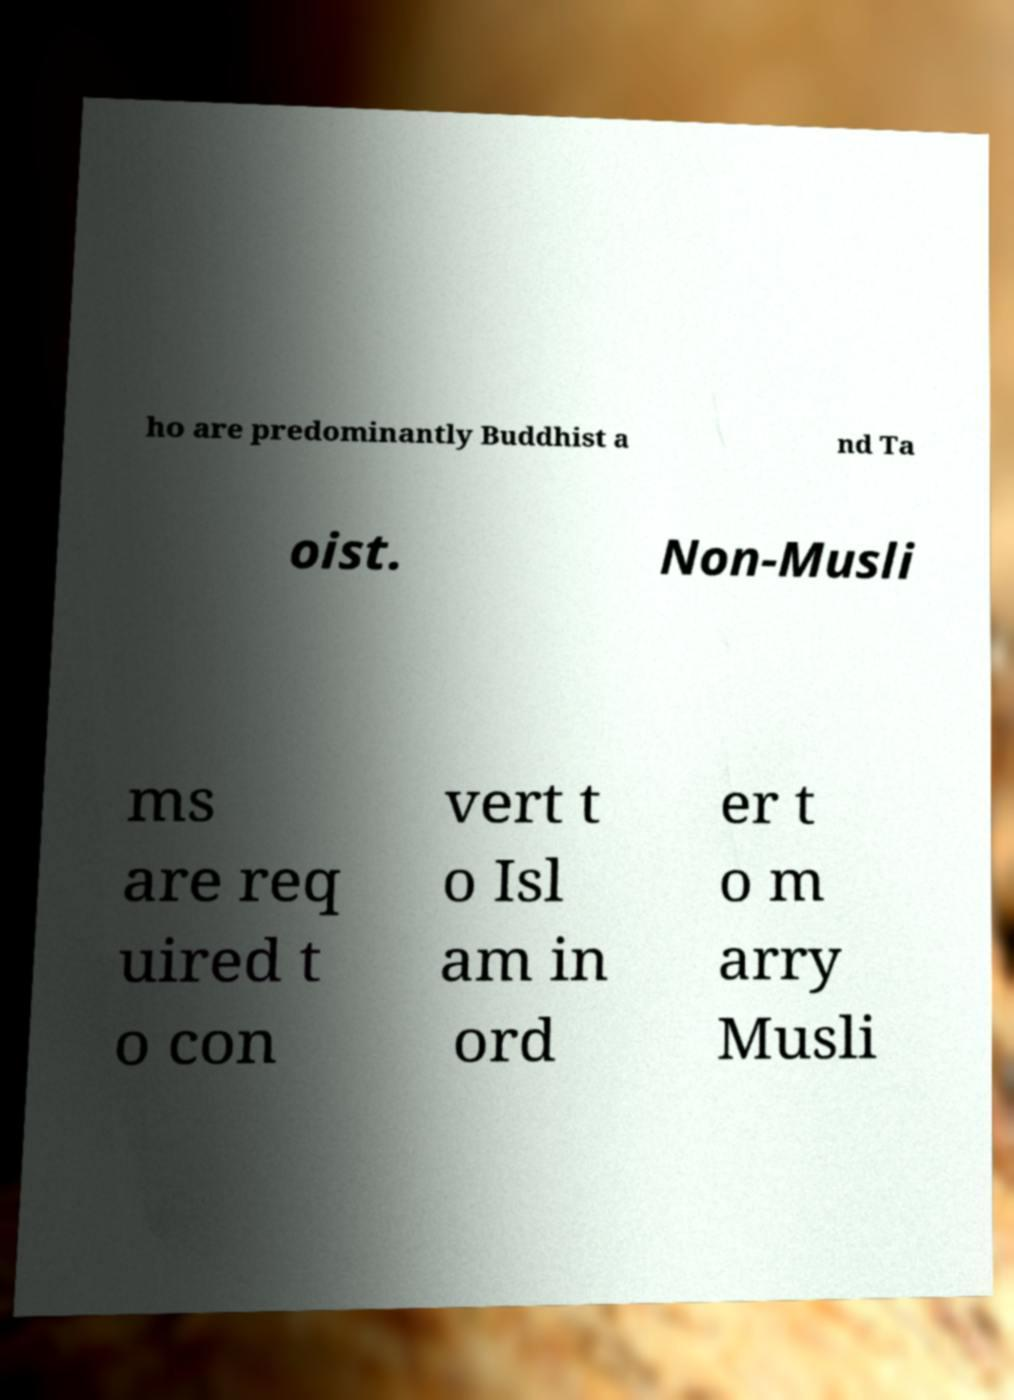Please read and relay the text visible in this image. What does it say? ho are predominantly Buddhist a nd Ta oist. Non-Musli ms are req uired t o con vert t o Isl am in ord er t o m arry Musli 